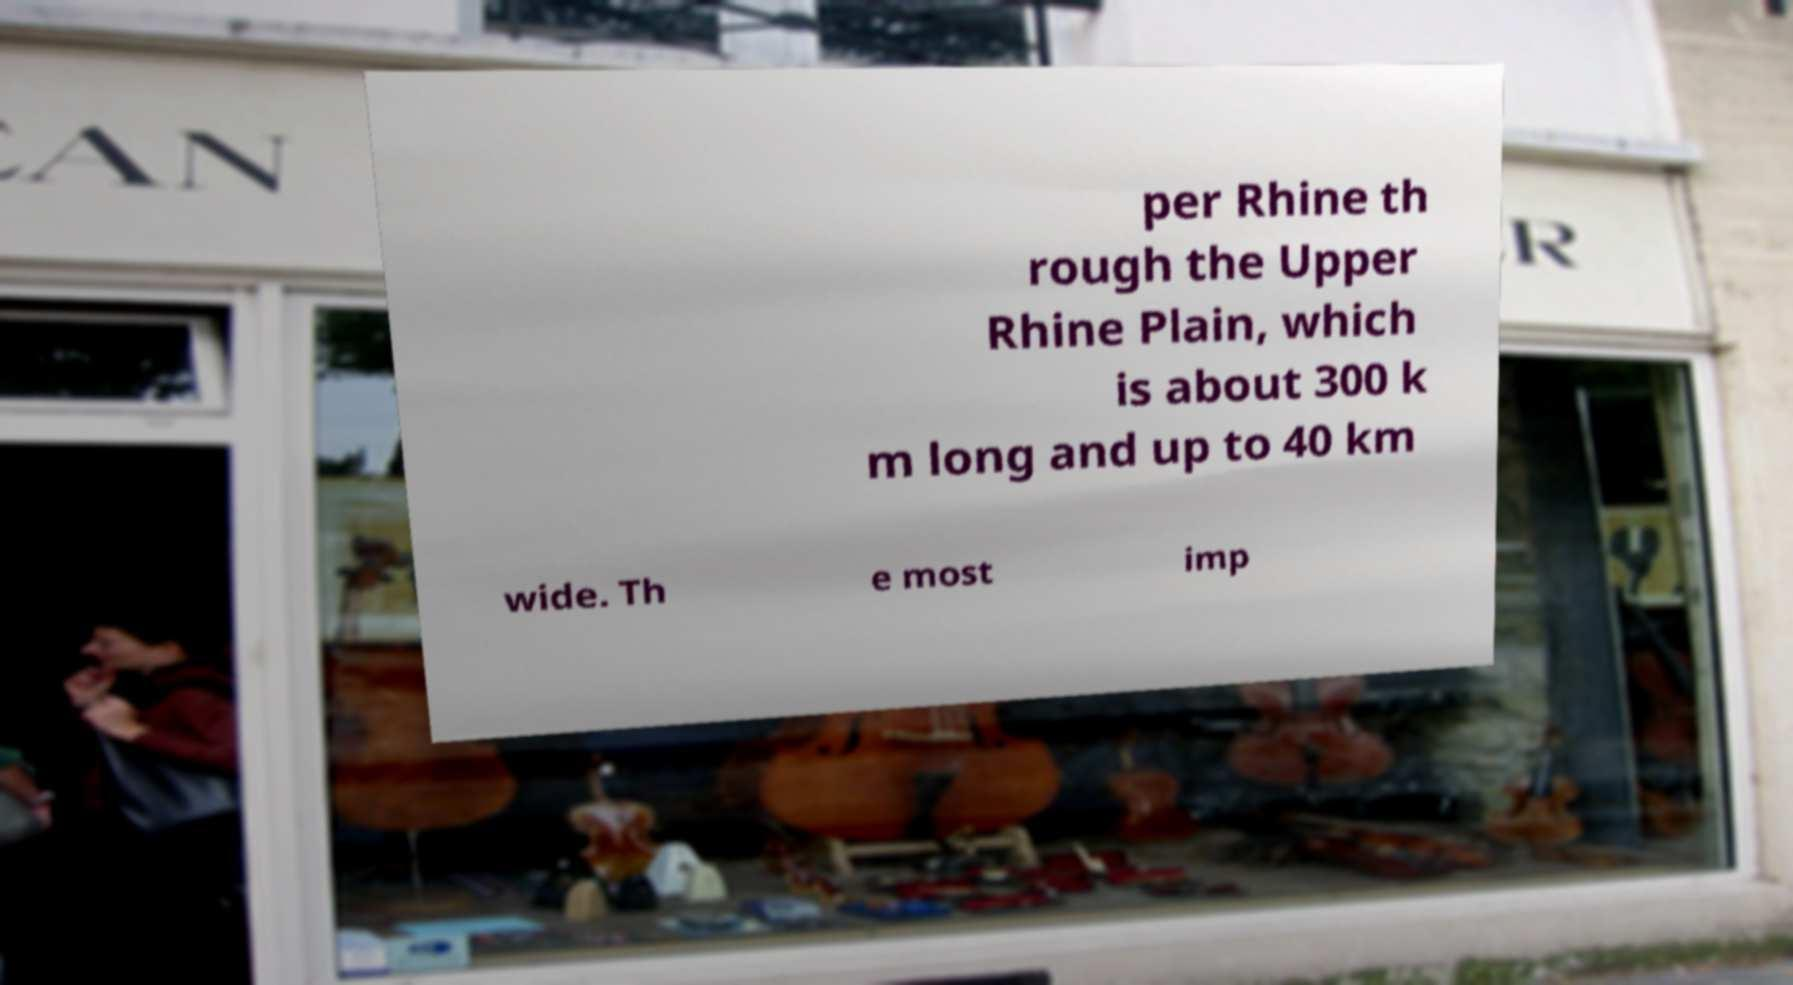There's text embedded in this image that I need extracted. Can you transcribe it verbatim? per Rhine th rough the Upper Rhine Plain, which is about 300 k m long and up to 40 km wide. Th e most imp 